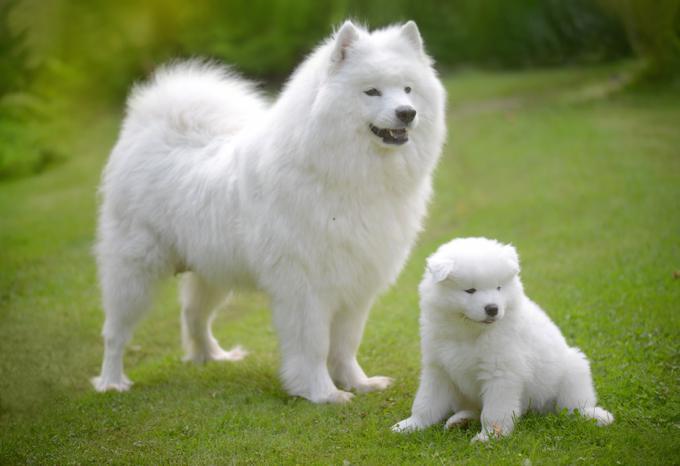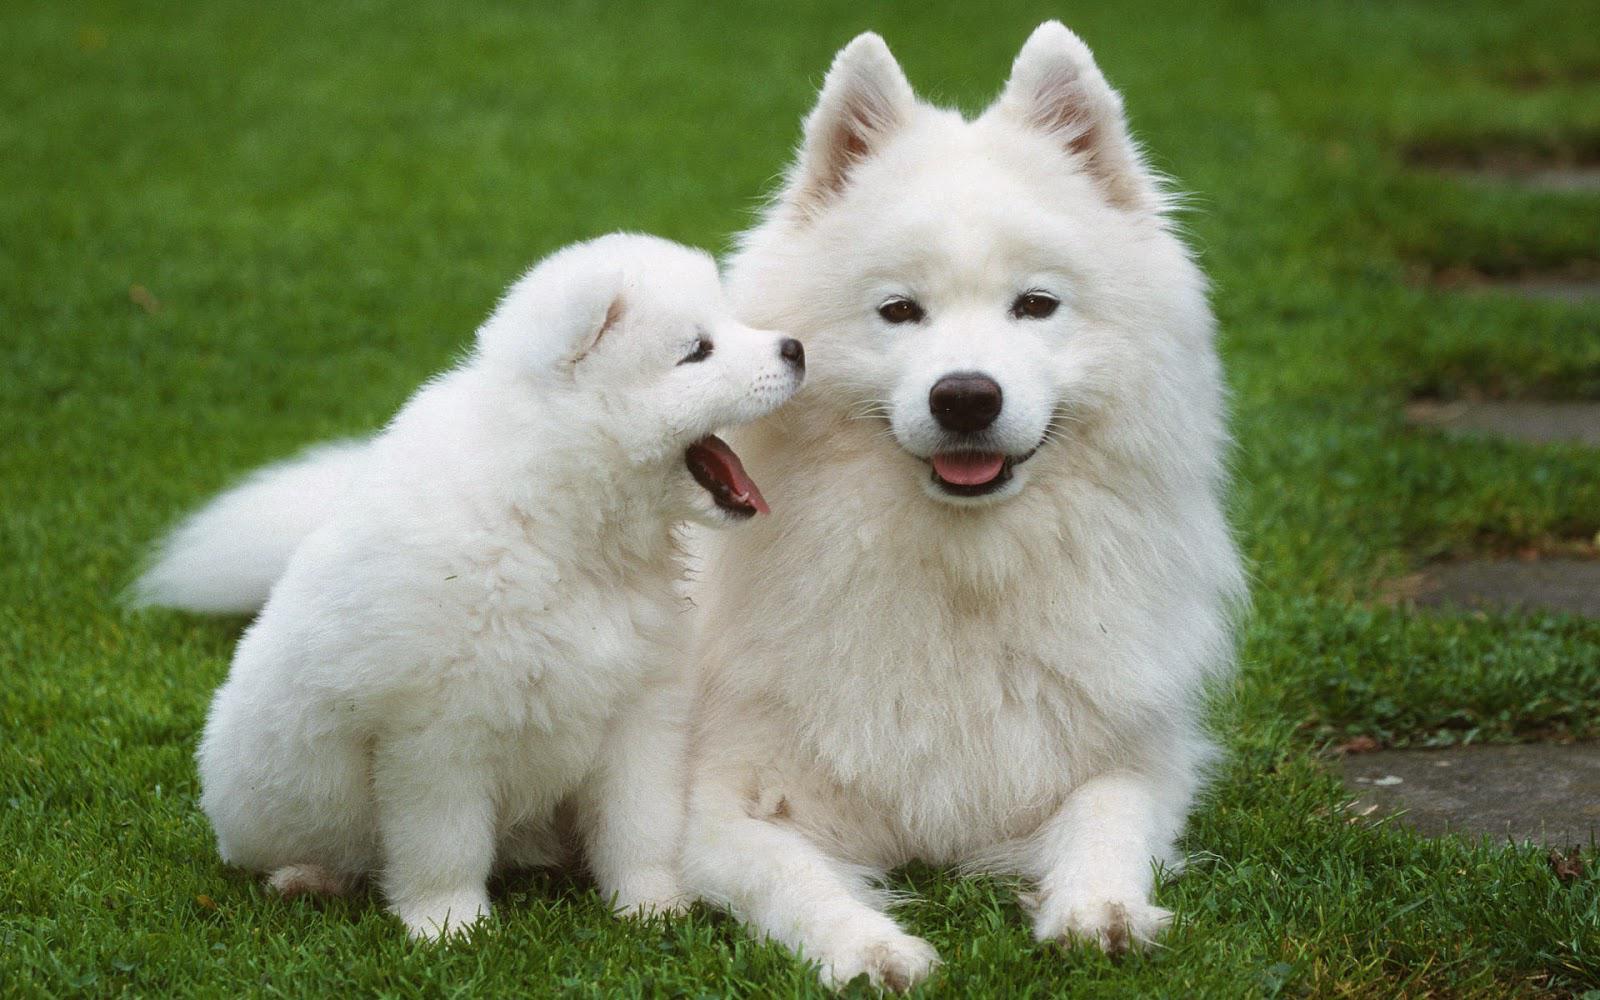The first image is the image on the left, the second image is the image on the right. Given the left and right images, does the statement "There are three dogs" hold true? Answer yes or no. No. The first image is the image on the left, the second image is the image on the right. Evaluate the accuracy of this statement regarding the images: "One of the images has exactly one dog.". Is it true? Answer yes or no. No. 